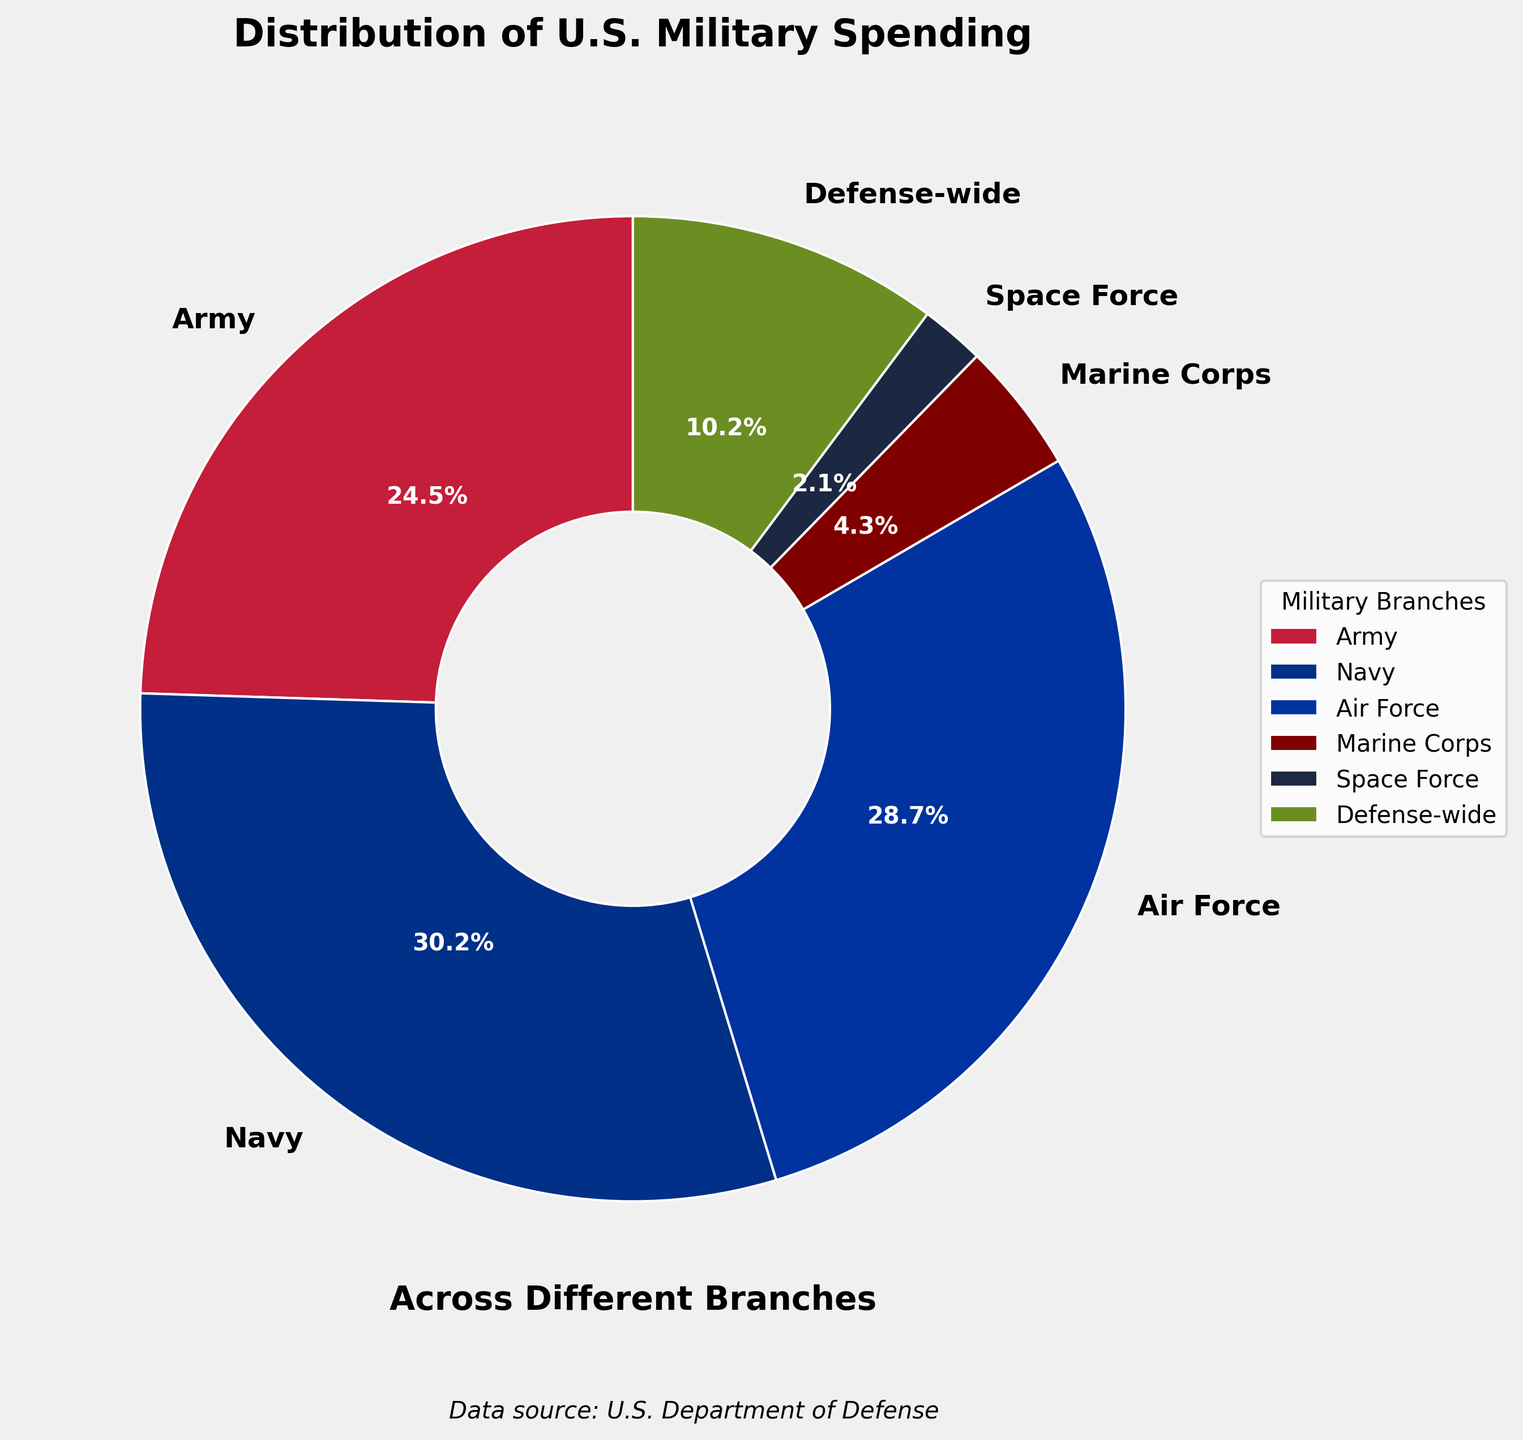What percentage of spending is accounted for by the Army and the Marine Corps combined? The Army accounts for 24.5% and the Marine Corps accounts for 4.3%. Together, their combined percentage is 24.5% + 4.3% = 28.8%.
Answer: 28.8% Which branch has the highest percentage of military spending? By examining the pie chart, the Navy has the highest percentage at 30.2%.
Answer: Navy How much more does the Air Force receive compared to the Marine Corps? The Air Force receives 28.7%, while the Marine Corps receives 4.3%. The difference is 28.7% - 4.3% = 24.4%.
Answer: 24.4% What is the combined percentage spent on the Space Force and Defense-wide expenditures? The Space Force receives 2.1% and Defense-wide expenditures account for 10.2%. Their combined percentage is 2.1% + 10.2% = 12.3%.
Answer: 12.3% Which branch is depicted in green on the pie chart? By looking at the keys and colors in the pie chart, the green section represents Defense-wide expenditures.
Answer: Defense-wide Is spending on the Navy greater than the combined spending on the Army and Marine Corps? Navy spending is 30.2%. Combined spending on the Army and Marine Corps is 24.5% + 4.3% = 28.8%. Since 30.2% > 28.8%, Navy spending is greater.
Answer: Yes Compare the spending on the Air Force and the Defense-wide programs. Which is higher? The Air Force spending is 28.7%, whereas Defense-wide programs receive 10.2%. Air Force spending is higher than Defense-wide programs.
Answer: Air Force Which branches account for less than 5% of the total spending? The pie chart shows that the Marine Corps has 4.3% and the Space Force has 2.1%, both of which are less than 5%.
Answer: Marine Corps and Space Force What fraction of defense spending is allocated to the Army, Navy, and Air Force combined? Combine the percentages: Army (24.5%), Navy (30.2%), and Air Force (28.7%). The total is 24.5% + 30.2% + 28.7% = 83.4%.
Answer: 83.4% What visual cues indicate the branch with the highest funding? The largest wedge in the pie chart corresponds to the Navy at 30.2%. It is colored blue and has a prominent position starting from the top right section of the chart.
Answer: The largest wedge in blue indicates the Navy 